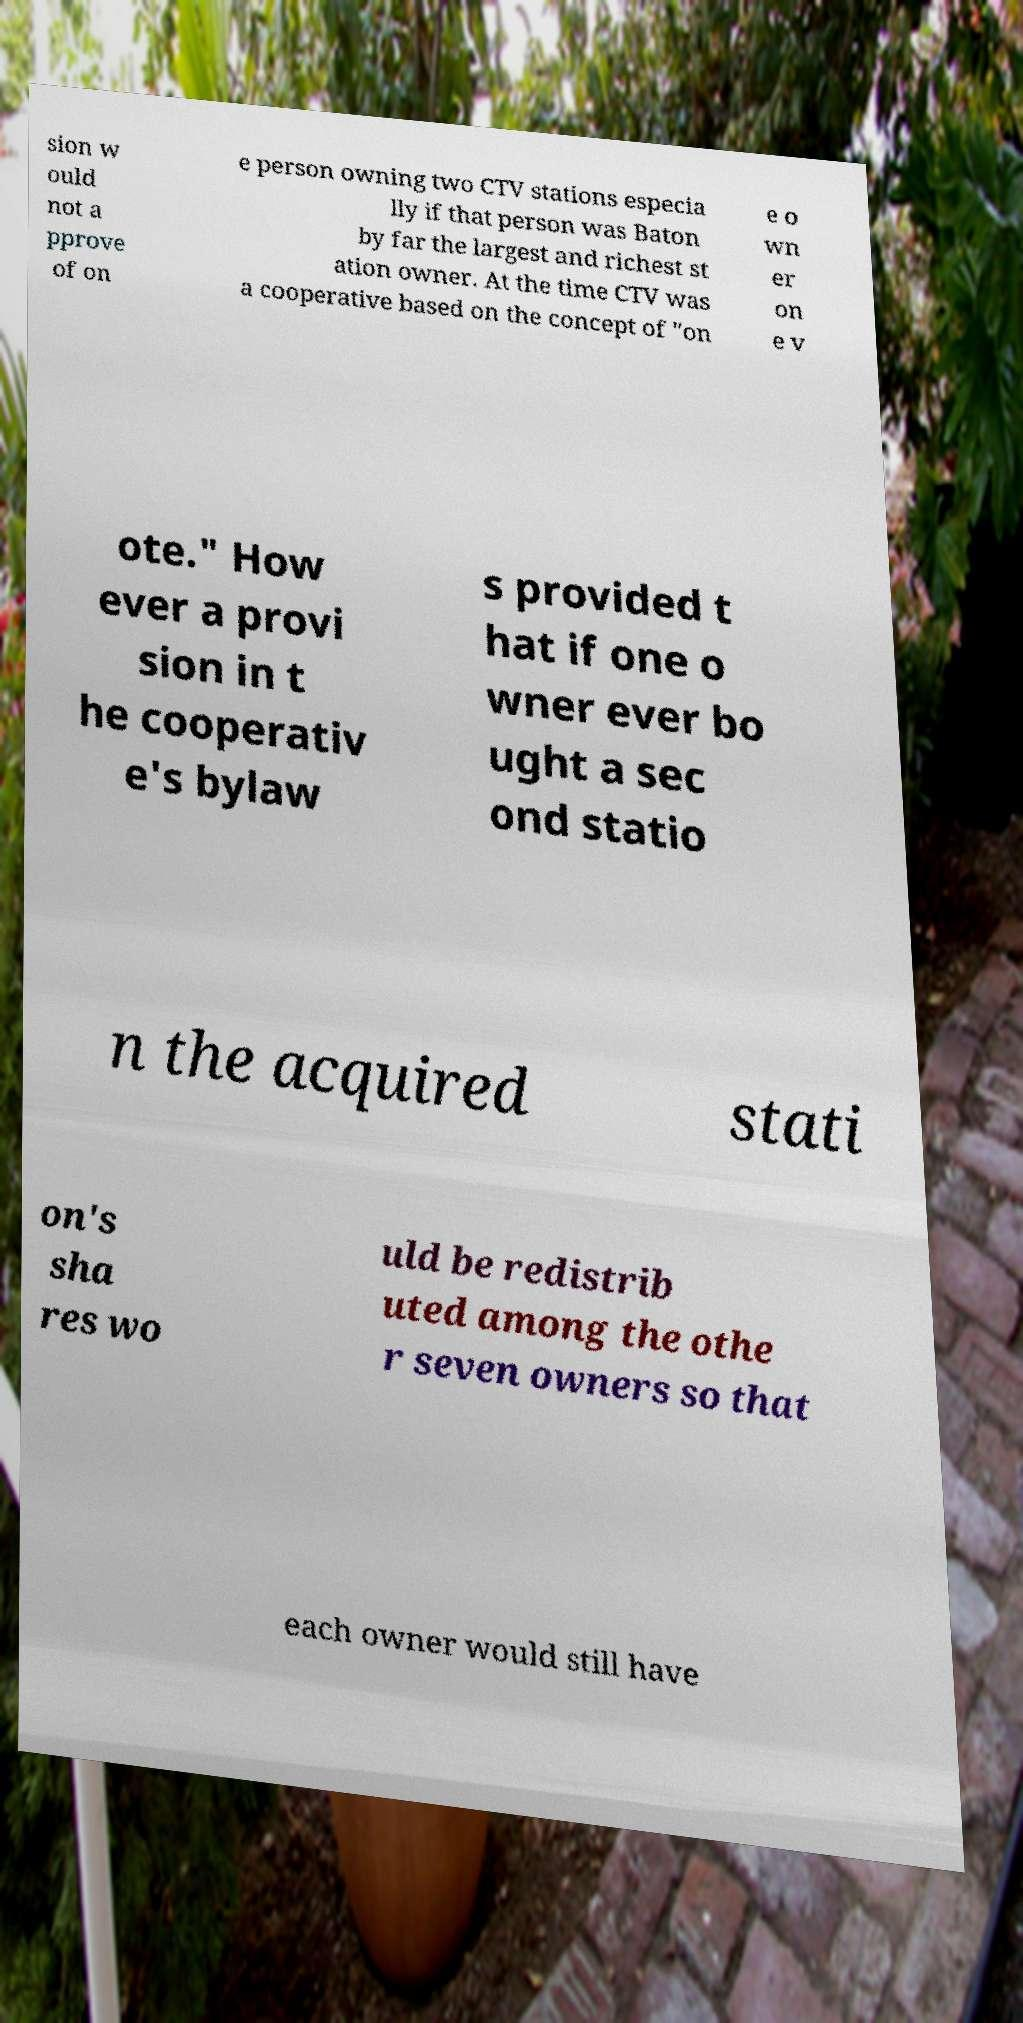For documentation purposes, I need the text within this image transcribed. Could you provide that? sion w ould not a pprove of on e person owning two CTV stations especia lly if that person was Baton by far the largest and richest st ation owner. At the time CTV was a cooperative based on the concept of "on e o wn er on e v ote." How ever a provi sion in t he cooperativ e's bylaw s provided t hat if one o wner ever bo ught a sec ond statio n the acquired stati on's sha res wo uld be redistrib uted among the othe r seven owners so that each owner would still have 